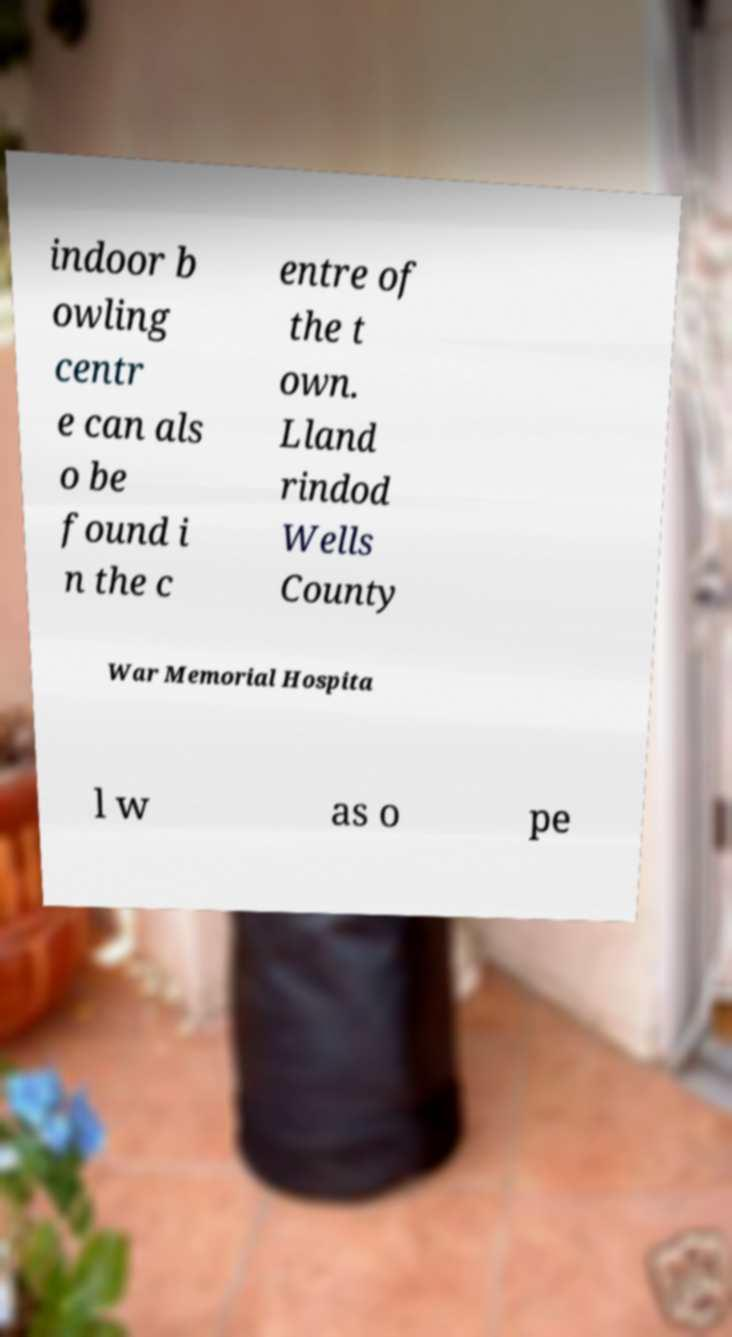For documentation purposes, I need the text within this image transcribed. Could you provide that? indoor b owling centr e can als o be found i n the c entre of the t own. Lland rindod Wells County War Memorial Hospita l w as o pe 